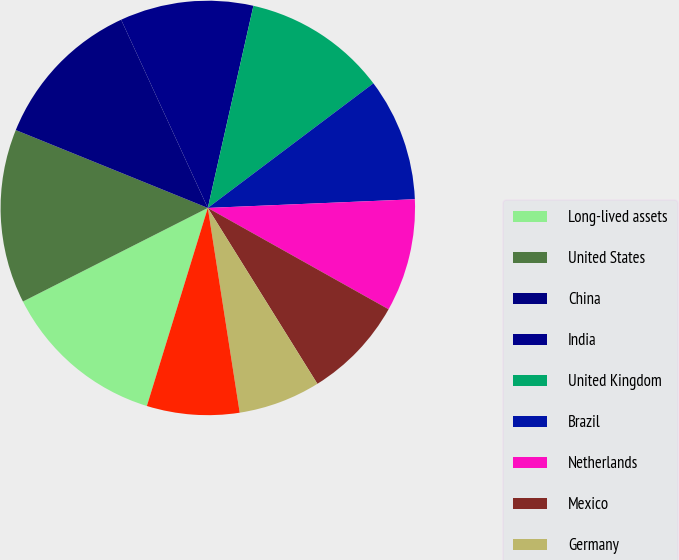Convert chart to OTSL. <chart><loc_0><loc_0><loc_500><loc_500><pie_chart><fcel>Long-lived assets<fcel>United States<fcel>China<fcel>India<fcel>United Kingdom<fcel>Brazil<fcel>Netherlands<fcel>Mexico<fcel>Germany<fcel>Canada<nl><fcel>12.79%<fcel>13.59%<fcel>12.0%<fcel>10.4%<fcel>11.2%<fcel>9.6%<fcel>8.8%<fcel>8.0%<fcel>6.41%<fcel>7.21%<nl></chart> 